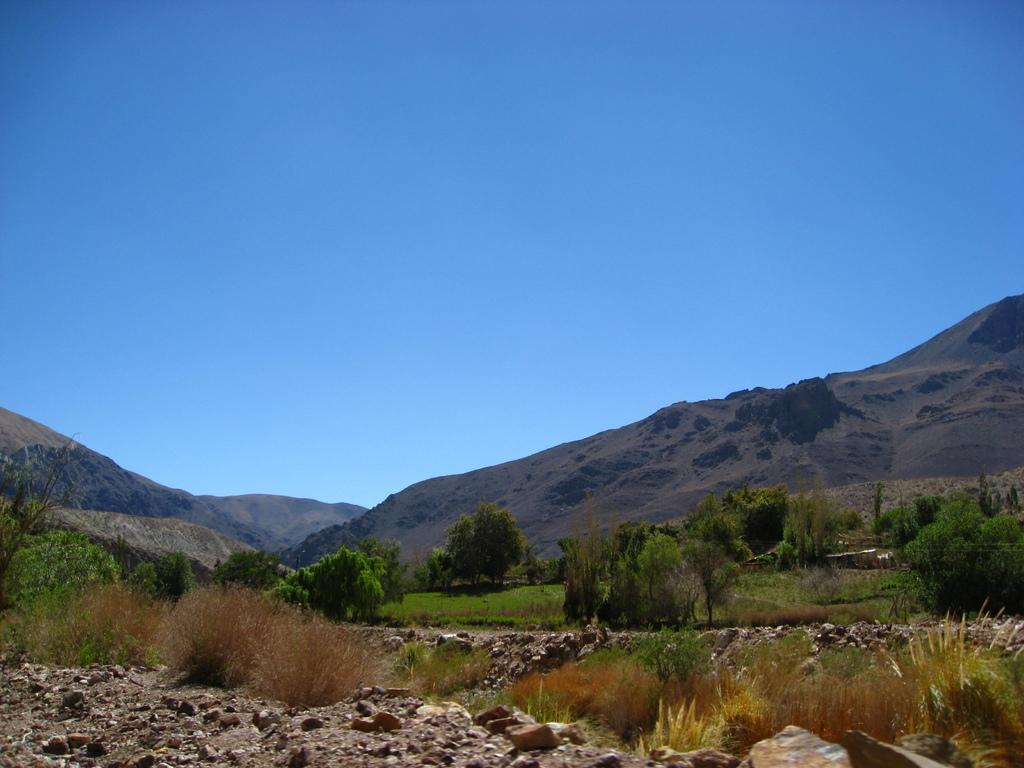What type of natural elements can be seen in the image? There are stones, plants, and trees visible in the image. What can be seen in the background of the image? There are mountains visible in the background of the image, and the sky is clear. What type of treatment is being administered to the stones in the image? There is no treatment being administered to the stones in the image; they are simply natural elements in the scene. 